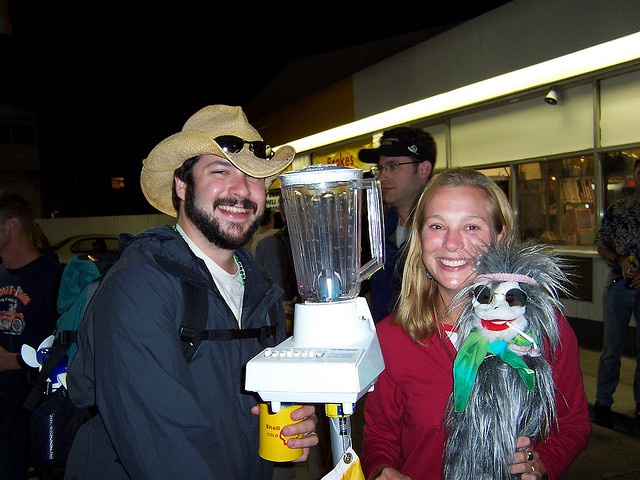Describe the objects in this image and their specific colors. I can see people in black, navy, tan, and darkgray tones, people in black, maroon, gray, and brown tones, people in black, maroon, gray, and navy tones, people in black, darkgreen, and navy tones, and people in black, brown, and maroon tones in this image. 